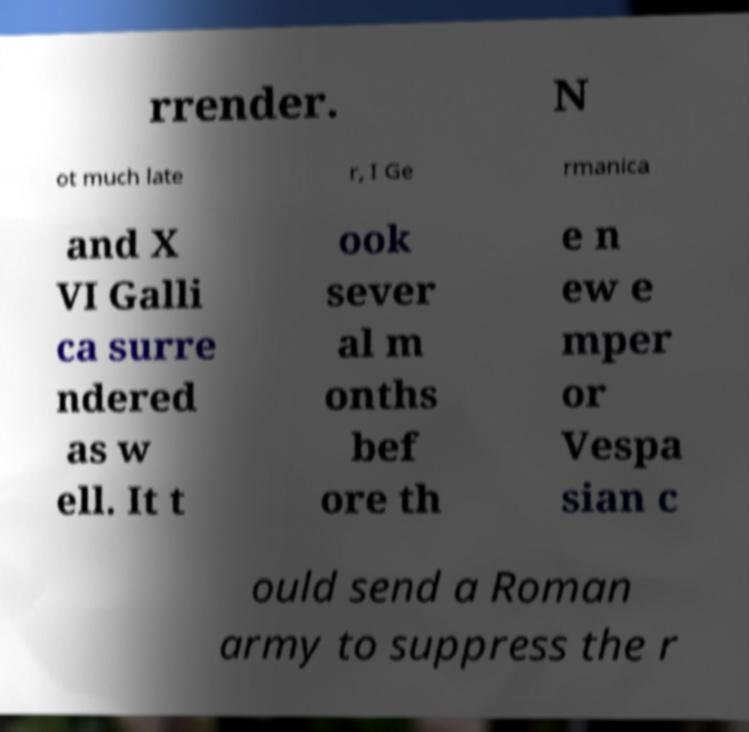Could you extract and type out the text from this image? rrender. N ot much late r, I Ge rmanica and X VI Galli ca surre ndered as w ell. It t ook sever al m onths bef ore th e n ew e mper or Vespa sian c ould send a Roman army to suppress the r 